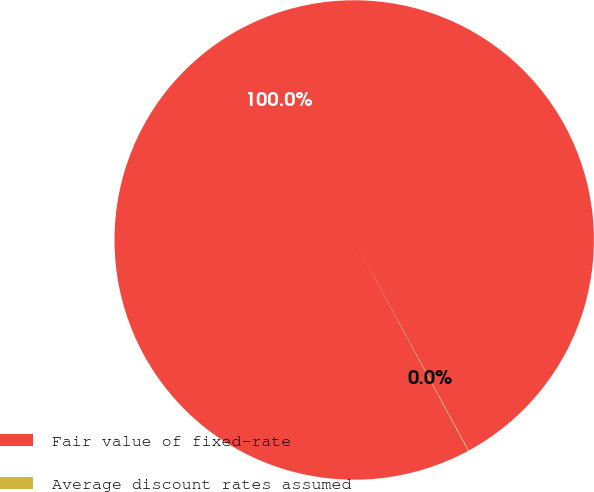Convert chart. <chart><loc_0><loc_0><loc_500><loc_500><pie_chart><fcel>Fair value of fixed-rate<fcel>Average discount rates assumed<nl><fcel>99.96%<fcel>0.04%<nl></chart> 